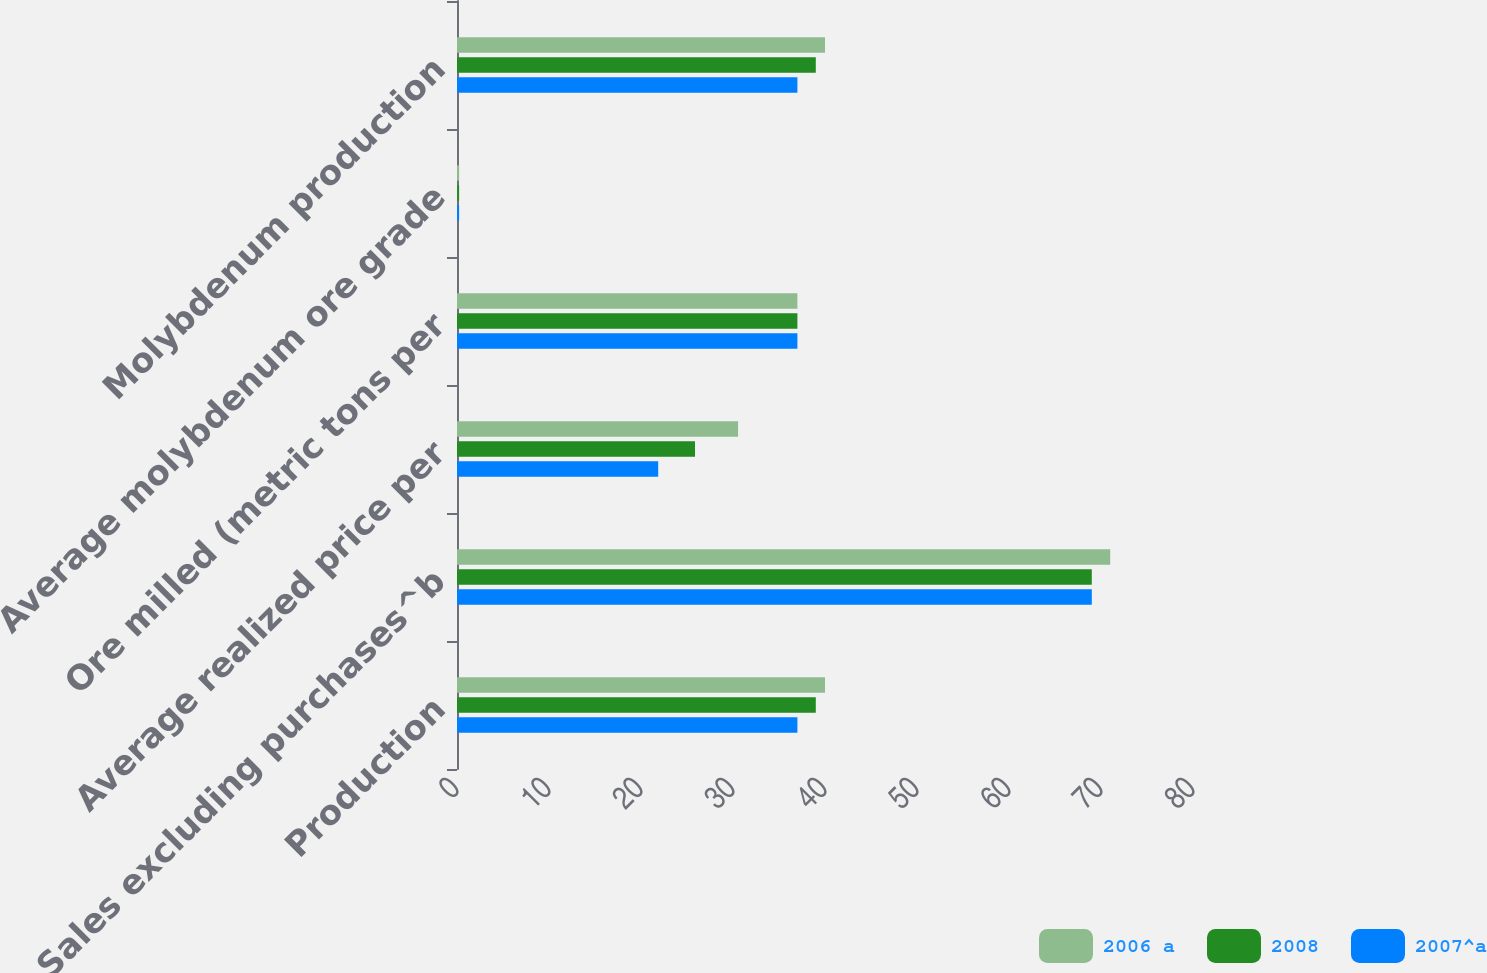Convert chart to OTSL. <chart><loc_0><loc_0><loc_500><loc_500><stacked_bar_chart><ecel><fcel>Production<fcel>Sales excluding purchases^b<fcel>Average realized price per<fcel>Ore milled (metric tons per<fcel>Average molybdenum ore grade<fcel>Molybdenum production<nl><fcel>2006 a<fcel>40<fcel>71<fcel>30.55<fcel>37<fcel>0.23<fcel>40<nl><fcel>2008<fcel>39<fcel>69<fcel>25.87<fcel>37<fcel>0.23<fcel>39<nl><fcel>2007^a<fcel>37<fcel>69<fcel>21.87<fcel>37<fcel>0.23<fcel>37<nl></chart> 